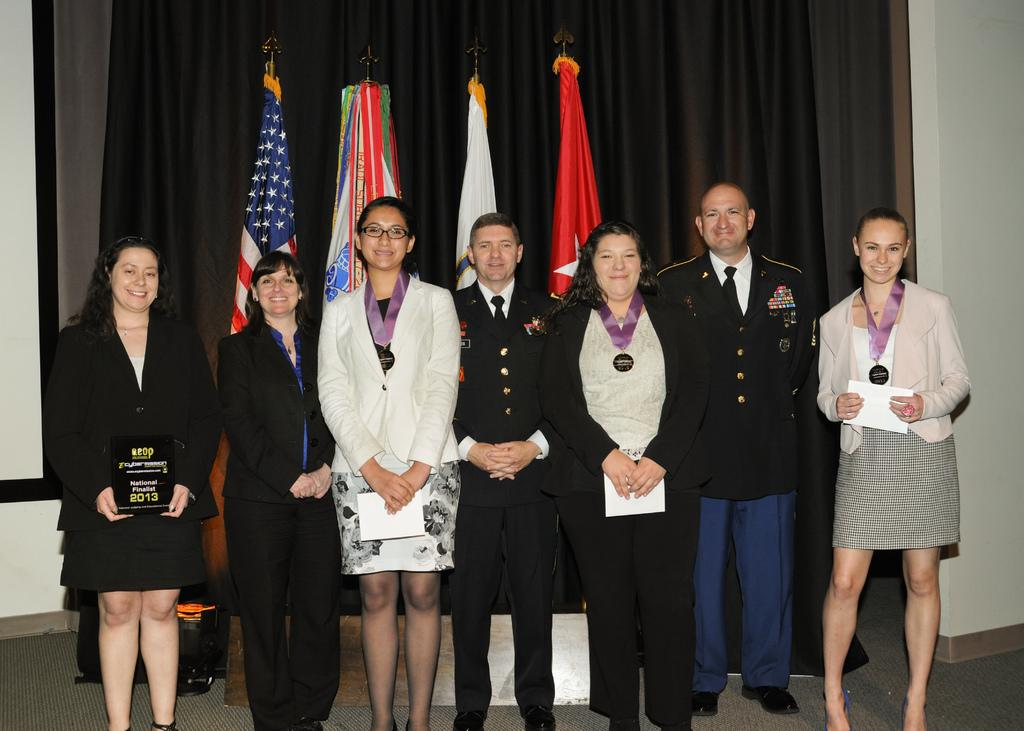What types of people are in the image? There are men and women in the image. What are the men and women doing in the image? The men and women are standing. What can be seen in the background of the image? There are flags and a black curtain in the background of the image. Is there a rainstorm happening in the image? No, there is no rainstorm depicted in the image. What type of class is being taught in the image? There is no class or teaching activity shown in the image. 